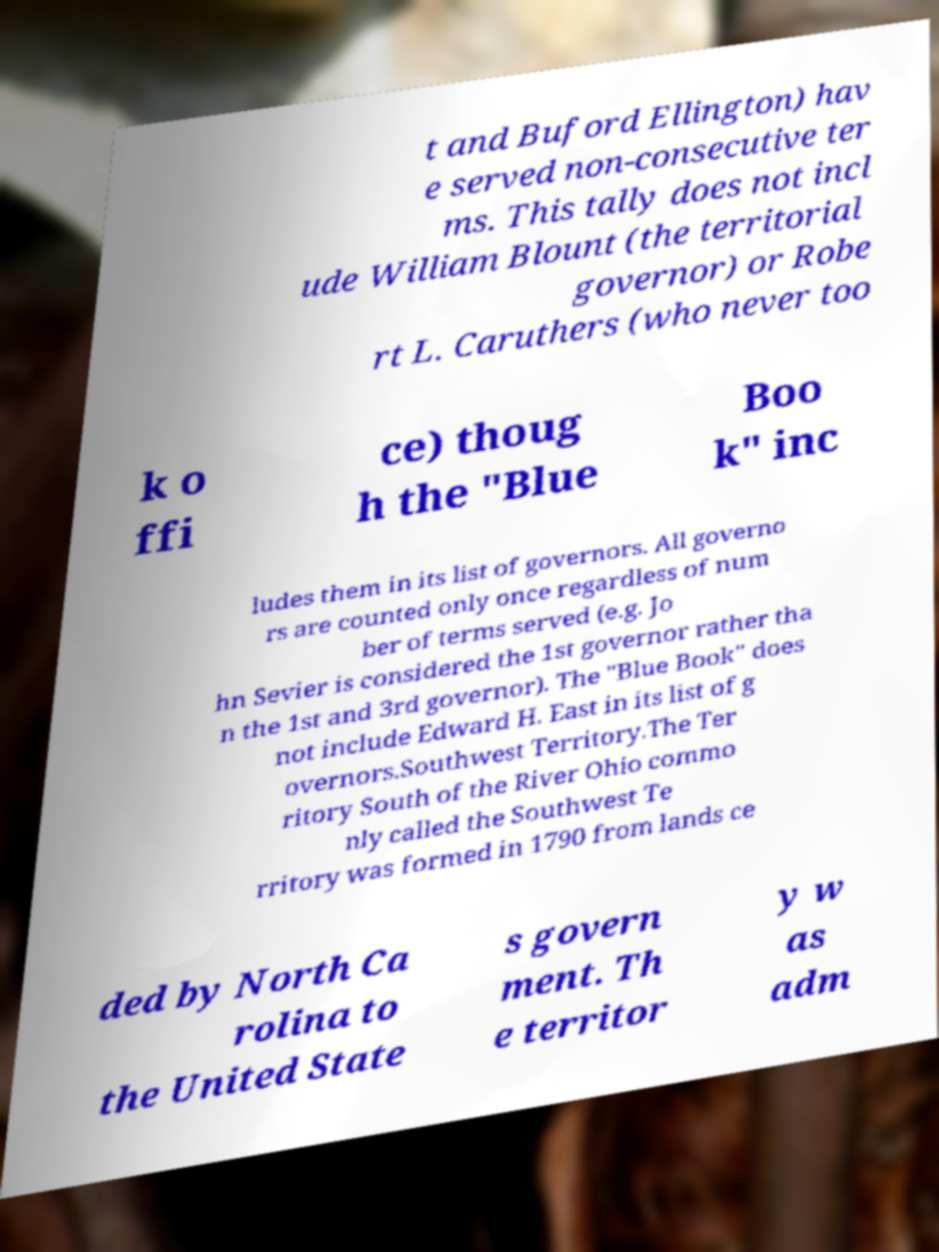Could you assist in decoding the text presented in this image and type it out clearly? t and Buford Ellington) hav e served non-consecutive ter ms. This tally does not incl ude William Blount (the territorial governor) or Robe rt L. Caruthers (who never too k o ffi ce) thoug h the "Blue Boo k" inc ludes them in its list of governors. All governo rs are counted only once regardless of num ber of terms served (e.g. Jo hn Sevier is considered the 1st governor rather tha n the 1st and 3rd governor). The "Blue Book" does not include Edward H. East in its list of g overnors.Southwest Territory.The Ter ritory South of the River Ohio commo nly called the Southwest Te rritory was formed in 1790 from lands ce ded by North Ca rolina to the United State s govern ment. Th e territor y w as adm 